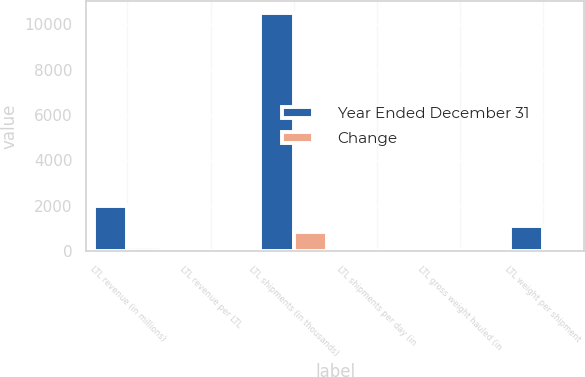Convert chart to OTSL. <chart><loc_0><loc_0><loc_500><loc_500><stacked_bar_chart><ecel><fcel>LTL revenue (in millions)<fcel>LTL revenue per LTL<fcel>LTL shipments (in thousands)<fcel>LTL shipments per day (in<fcel>LTL gross weight hauled (in<fcel>LTL weight per shipment<nl><fcel>Year Ended December 31<fcel>2013<fcel>17.41<fcel>10481<fcel>41.4<fcel>90<fcel>1103<nl><fcel>Change<fcel>182<fcel>1.48<fcel>843<fcel>3.2<fcel>62<fcel>90<nl></chart> 